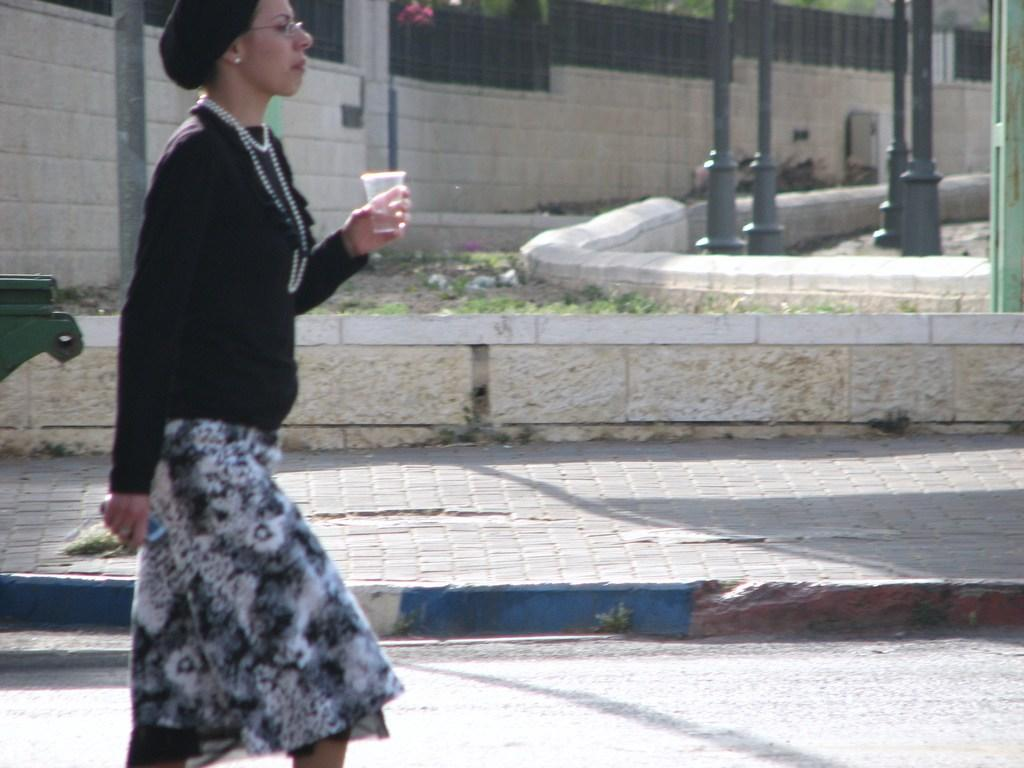What types of living organisms can be seen in the image? Plants and flowers are visible in the image. What is the person in the image holding? The person is holding a glass in the image. What type of infrastructure can be seen in the image? There is a road, a path, poles, and a wall with fencing in the image. Can you describe the object on the left side of the image? Unfortunately, the facts provided do not specify the nature of the object on the left side of the image. What type of pail can be seen in the image? There is no pail present in the image. 